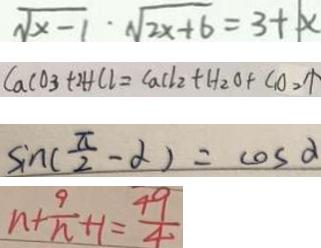<formula> <loc_0><loc_0><loc_500><loc_500>\sqrt { x - 1 } \cdot \sqrt { 2 x + 6 } = 3 + \vert x 
 C a C O _ { 3 } + 2 H C l = C a C l _ { 2 } + H _ { 2 } O + C _ { 1 } O _ { 2 } \uparrow 
 \sin ( \frac { \pi } { 2 } - \alpha ) = \cos \alpha 
 n + \frac { 9 } { n } + 1 = \frac { 4 9 } { 4 }</formula> 